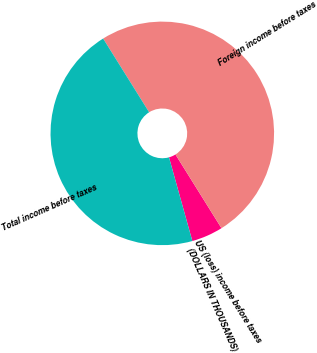Convert chart to OTSL. <chart><loc_0><loc_0><loc_500><loc_500><pie_chart><fcel>(DOLLARS IN THOUSANDS)<fcel>US (loss) income before taxes<fcel>Foreign income before taxes<fcel>Total income before taxes<nl><fcel>4.55%<fcel>0.0%<fcel>50.0%<fcel>45.45%<nl></chart> 